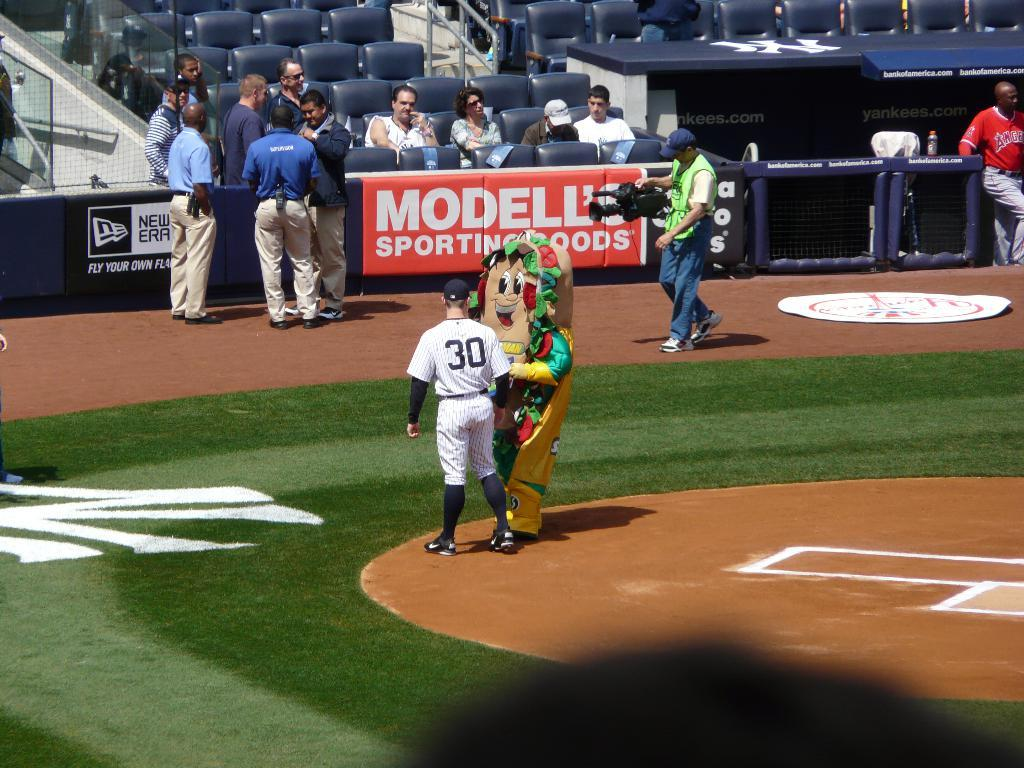<image>
Describe the image concisely. A man dressed as a large submarine sandwich is standing on a baseball field, in front of a banner, advertising Modelle Sporting Goods. 